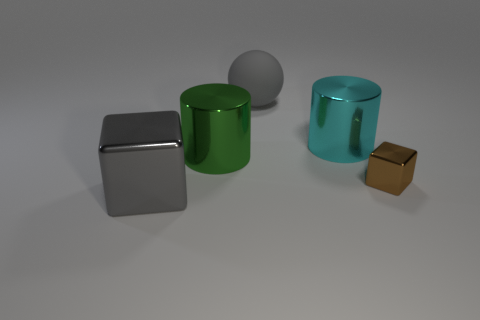Add 1 small purple metallic cylinders. How many objects exist? 6 Subtract all cylinders. How many objects are left? 3 Add 5 small gray spheres. How many small gray spheres exist? 5 Subtract 0 blue cylinders. How many objects are left? 5 Subtract all tiny purple cubes. Subtract all big metal cylinders. How many objects are left? 3 Add 2 large objects. How many large objects are left? 6 